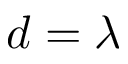<formula> <loc_0><loc_0><loc_500><loc_500>d = \lambda</formula> 